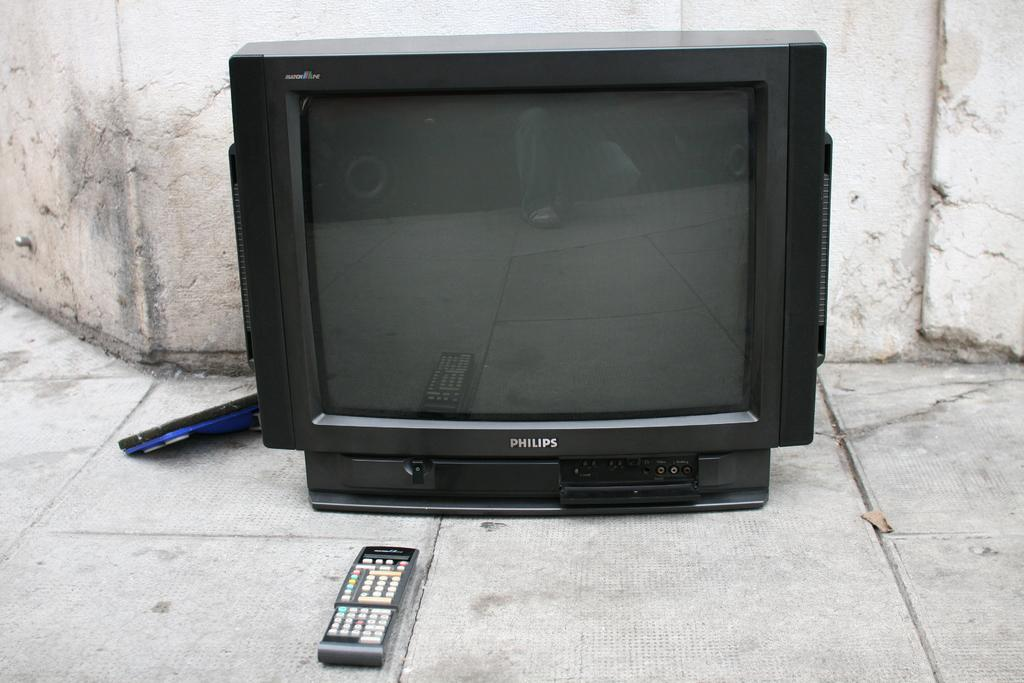<image>
Write a terse but informative summary of the picture. A Phillips television is turned off with the remote sitting in front of it. 